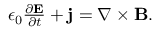Convert formula to latex. <formula><loc_0><loc_0><loc_500><loc_500>\begin{array} { r } { \epsilon _ { 0 } \frac { \partial E } { \partial t } + j = \nabla \times B . } \end{array}</formula> 